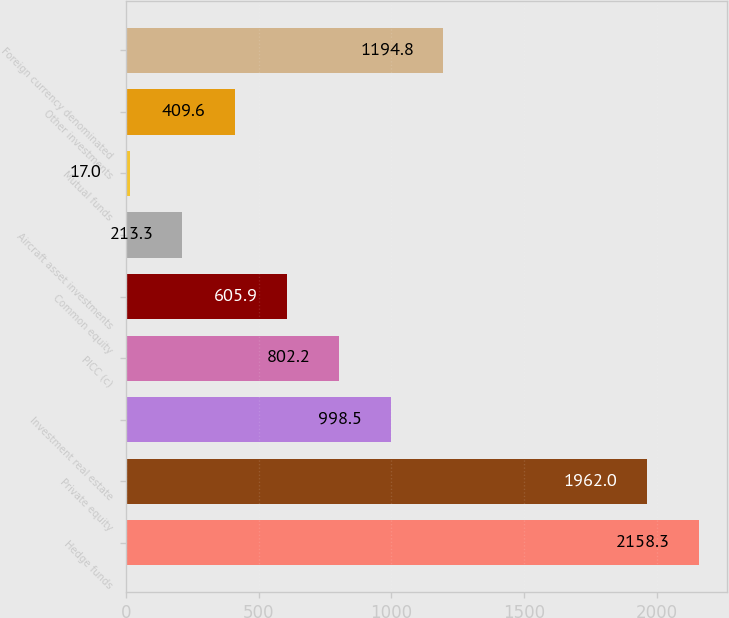<chart> <loc_0><loc_0><loc_500><loc_500><bar_chart><fcel>Hedge funds<fcel>Private equity<fcel>Investment real estate<fcel>PICC (c)<fcel>Common equity<fcel>Aircraft asset investments<fcel>Mutual funds<fcel>Other investments<fcel>Foreign currency denominated<nl><fcel>2158.3<fcel>1962<fcel>998.5<fcel>802.2<fcel>605.9<fcel>213.3<fcel>17<fcel>409.6<fcel>1194.8<nl></chart> 